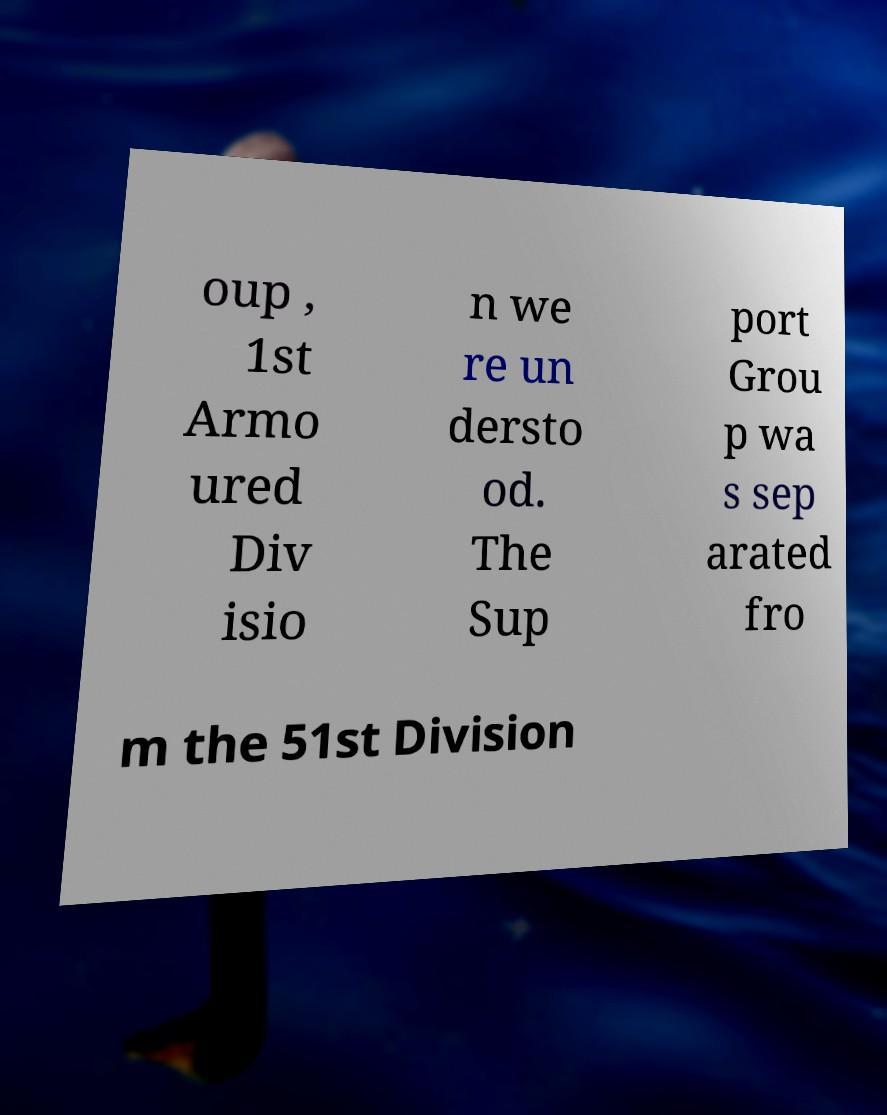Could you extract and type out the text from this image? oup , 1st Armo ured Div isio n we re un dersto od. The Sup port Grou p wa s sep arated fro m the 51st Division 